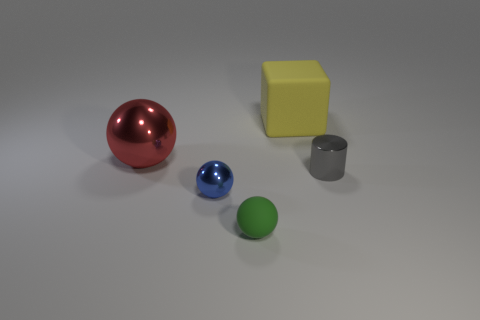Are there an equal number of yellow blocks to the left of the small matte ball and yellow things that are right of the large red thing?
Keep it short and to the point. No. What is the small blue object made of?
Give a very brief answer. Metal. What is the material of the tiny object that is right of the green ball?
Make the answer very short. Metal. Is the number of green rubber balls that are on the right side of the big metallic ball greater than the number of small brown metallic cylinders?
Your answer should be compact. Yes. Is there a large object that is left of the ball that is right of the metallic sphere that is to the right of the red thing?
Your answer should be very brief. Yes. Are there any tiny metal things to the right of the tiny blue sphere?
Make the answer very short. Yes. The object that is made of the same material as the big block is what size?
Offer a very short reply. Small. There is a matte object that is in front of the matte thing to the right of the matte object in front of the red object; how big is it?
Give a very brief answer. Small. What size is the metallic sphere that is in front of the metal cylinder?
Provide a short and direct response. Small. What number of gray things are small rubber spheres or small things?
Provide a succinct answer. 1. 